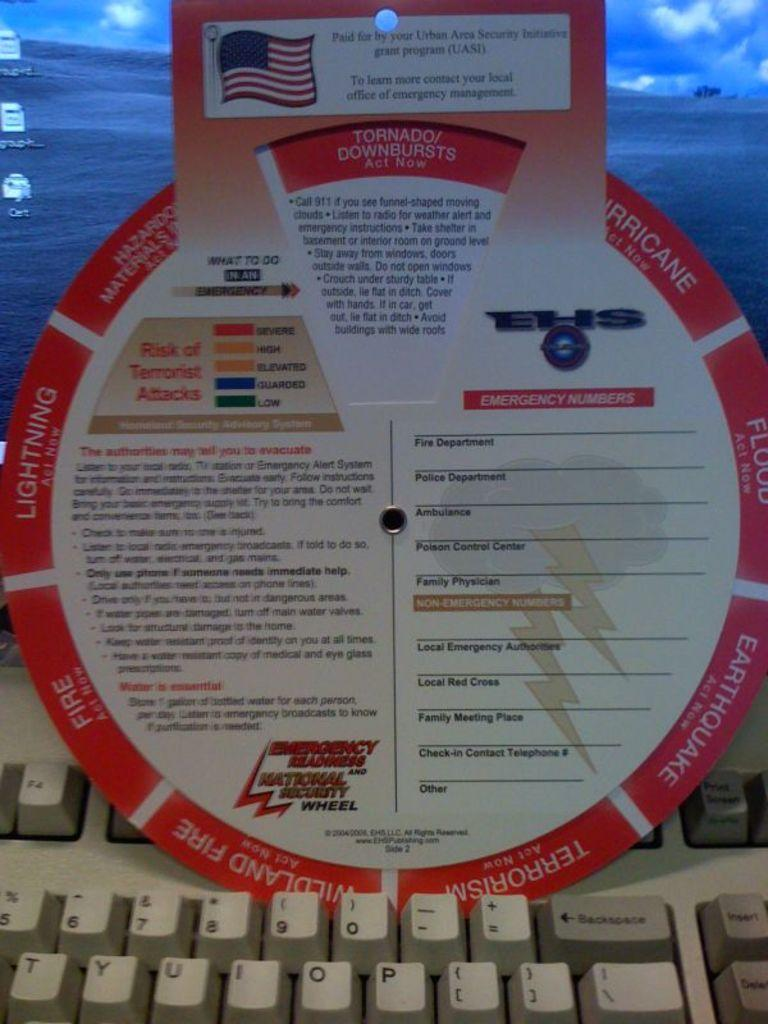<image>
Create a compact narrative representing the image presented. An emergency security wheel sitting on top of a computer keyboard. 